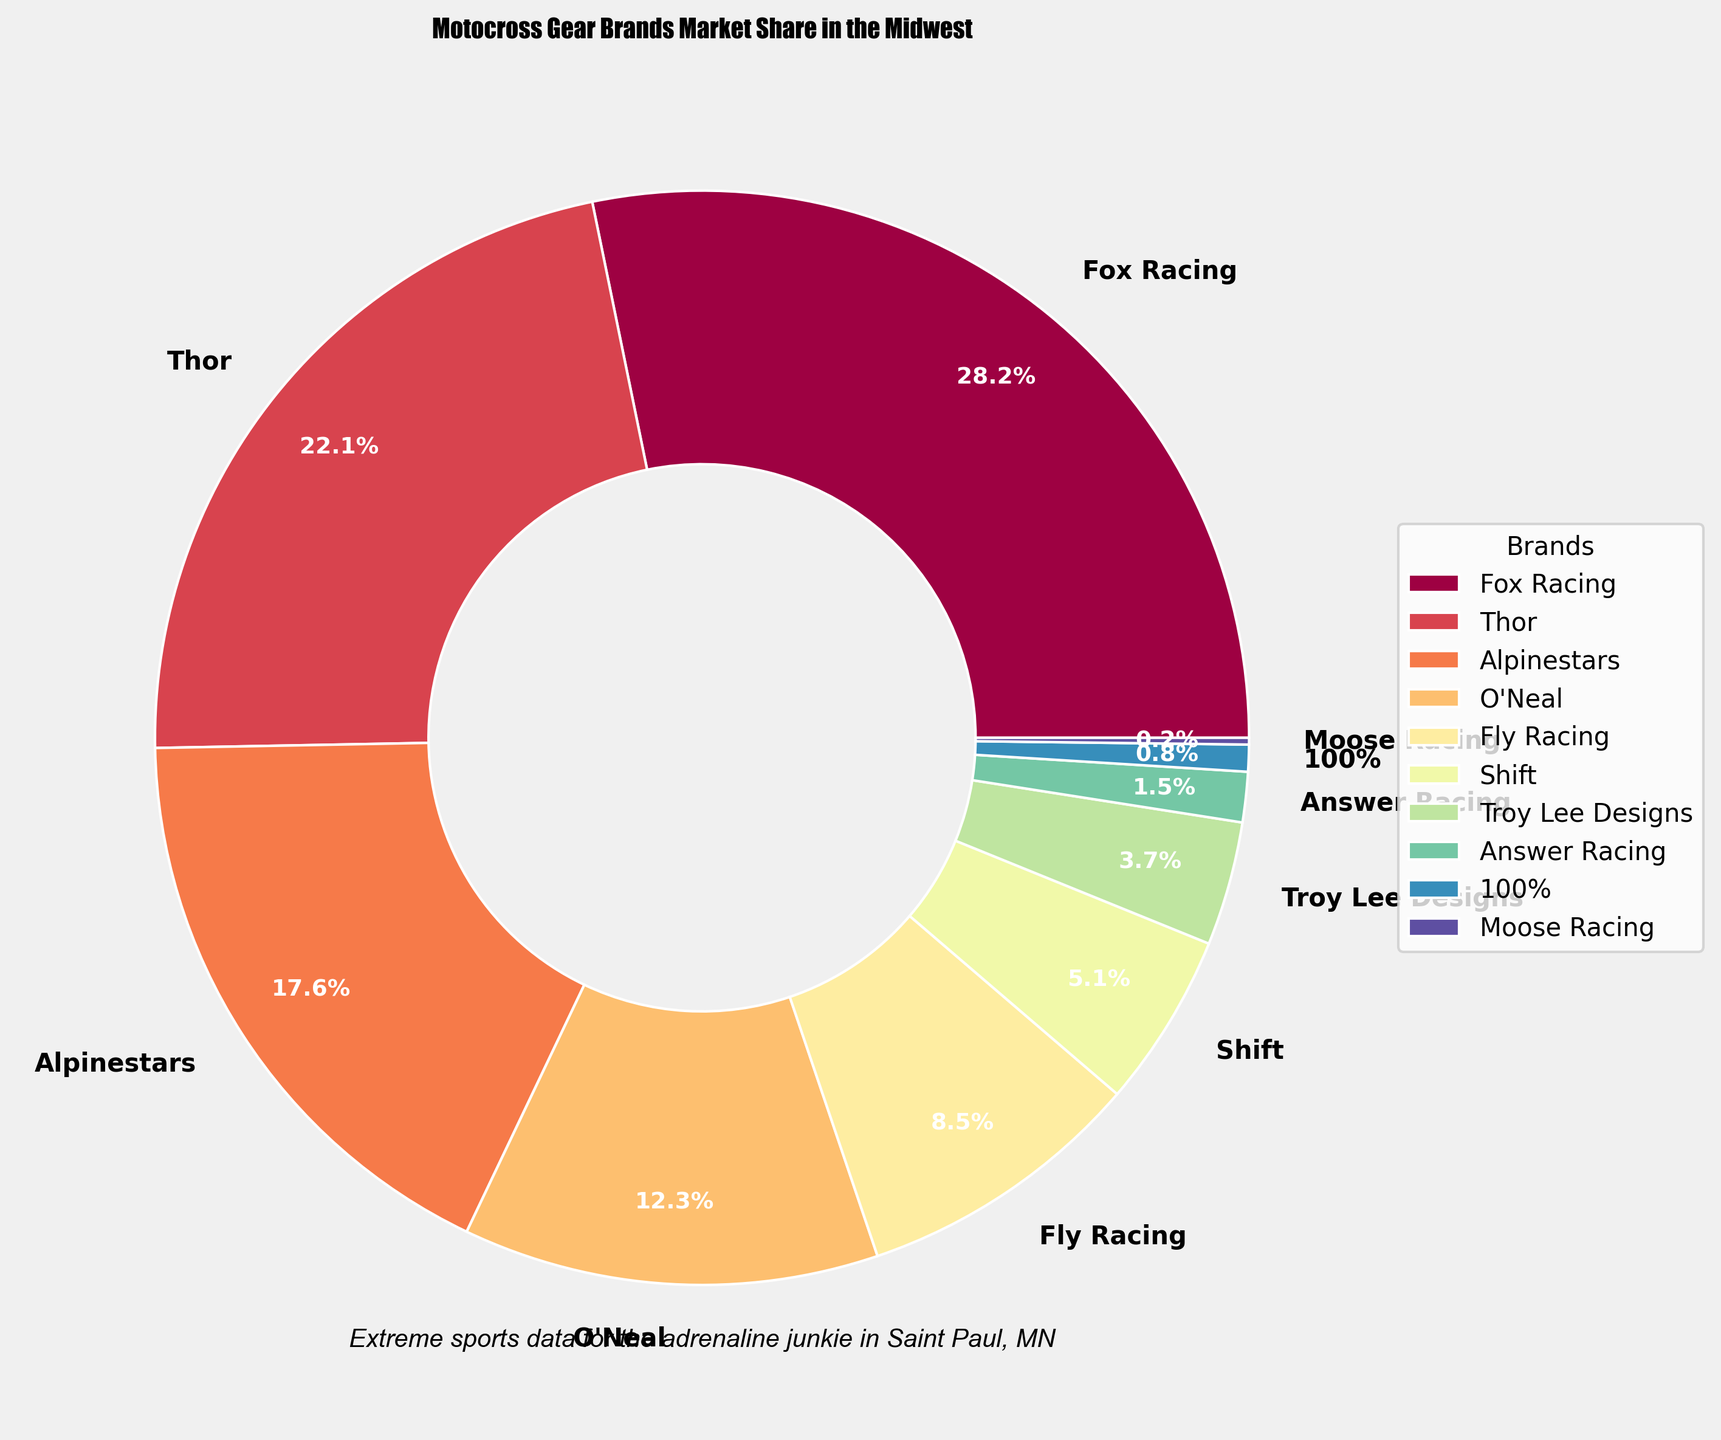what is the brand with the highest market share? Look at the figure and find the slice with the largest percentage label. The Fox Racing slice is the largest one.
Answer: Fox Racing How much higher is Fox Racing's market share compared to Thor? Fox Racing has a market share of 28.5%, while Thor has a market share of 22.3%. The difference is 28.5% - 22.3% = 6.2%.
Answer: 6.2% What is the total market share of Alpinestars, Shift, and O'Neal combined? The market share for Alpinestars is 17.8%, for Shift is 5.2%, and for O'Neal is 12.4%. Adding them together gives 17.8% + 5.2% + 12.4% = 35.4%.
Answer: 35.4% Is the market share of Fly Racing more than twice that of Troy Lee Designs? Fly Racing has a market share of 8.6% and Troy Lee Designs has 3.7%. Twice of Troy Lee Designs' market share is 3.7% * 2 = 7.4%. Since 8.6% is more than 7.4%, the answer is yes.
Answer: Yes Which brand has the smallest market share, and what is their percentage? Look for the smallest slice in the pie chart, which corresponds to Moose Racing with a market share of 0.2%.
Answer: Moose Racing, 0.2% What is the average market share of the brands with more than 20% market share? Only Fox Racing and Thor have more than 20% market share with 28.5% and 22.3% respectively. The average is (28.5% + 22.3%) / 2 = 25.4%.
Answer: 25.4% How much more is O'Neal's market share compared to 100%'s market share? O'Neal has a market share of 12.4%, while 100% has 0.8%. The difference is 12.4% - 0.8% = 11.6%.
Answer: 11.6% Which brands have a market share less than Fly Racing but more than Answer Racing? Fly Racing has a market share of 8.6%, and Answer Racing has 1.5%. The brands that fall between these ranges are Shift with 5.2% and Troy Lee Designs with 3.7%.
Answer: Shift, Troy Lee Designs What's the combined market share of all brands with less than 5%? The brands with less than 5% are Shift, Troy Lee Designs, Answer Racing, 100%, and Moose Racing. Add their market shares: 5.2% + 3.7% + 1.5% + 0.8% + 0.2% = 11.4%.
Answer: 11.4% How does the market share of Thor compare to O'Neal and Fly Racing combined? Thor has a market share of 22.3%, while O'Neal has 12.4% and Fly Racing has 8.6%. Combined, O'Neal and Fly Racing have 12.4% + 8.6% = 21%. Thor's market share is higher by 22.3% - 21% = 1.3%.
Answer: Thor's market share is higher by 1.3% 